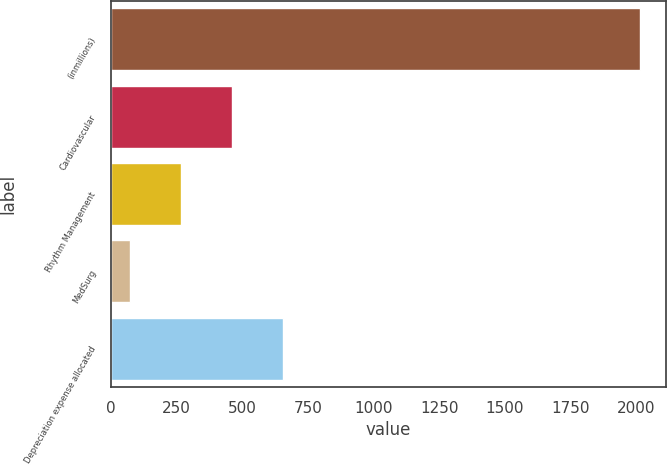<chart> <loc_0><loc_0><loc_500><loc_500><bar_chart><fcel>(inmillions)<fcel>Cardiovascular<fcel>Rhythm Management<fcel>MedSurg<fcel>Depreciation expense allocated<nl><fcel>2013<fcel>461<fcel>267<fcel>73<fcel>655<nl></chart> 